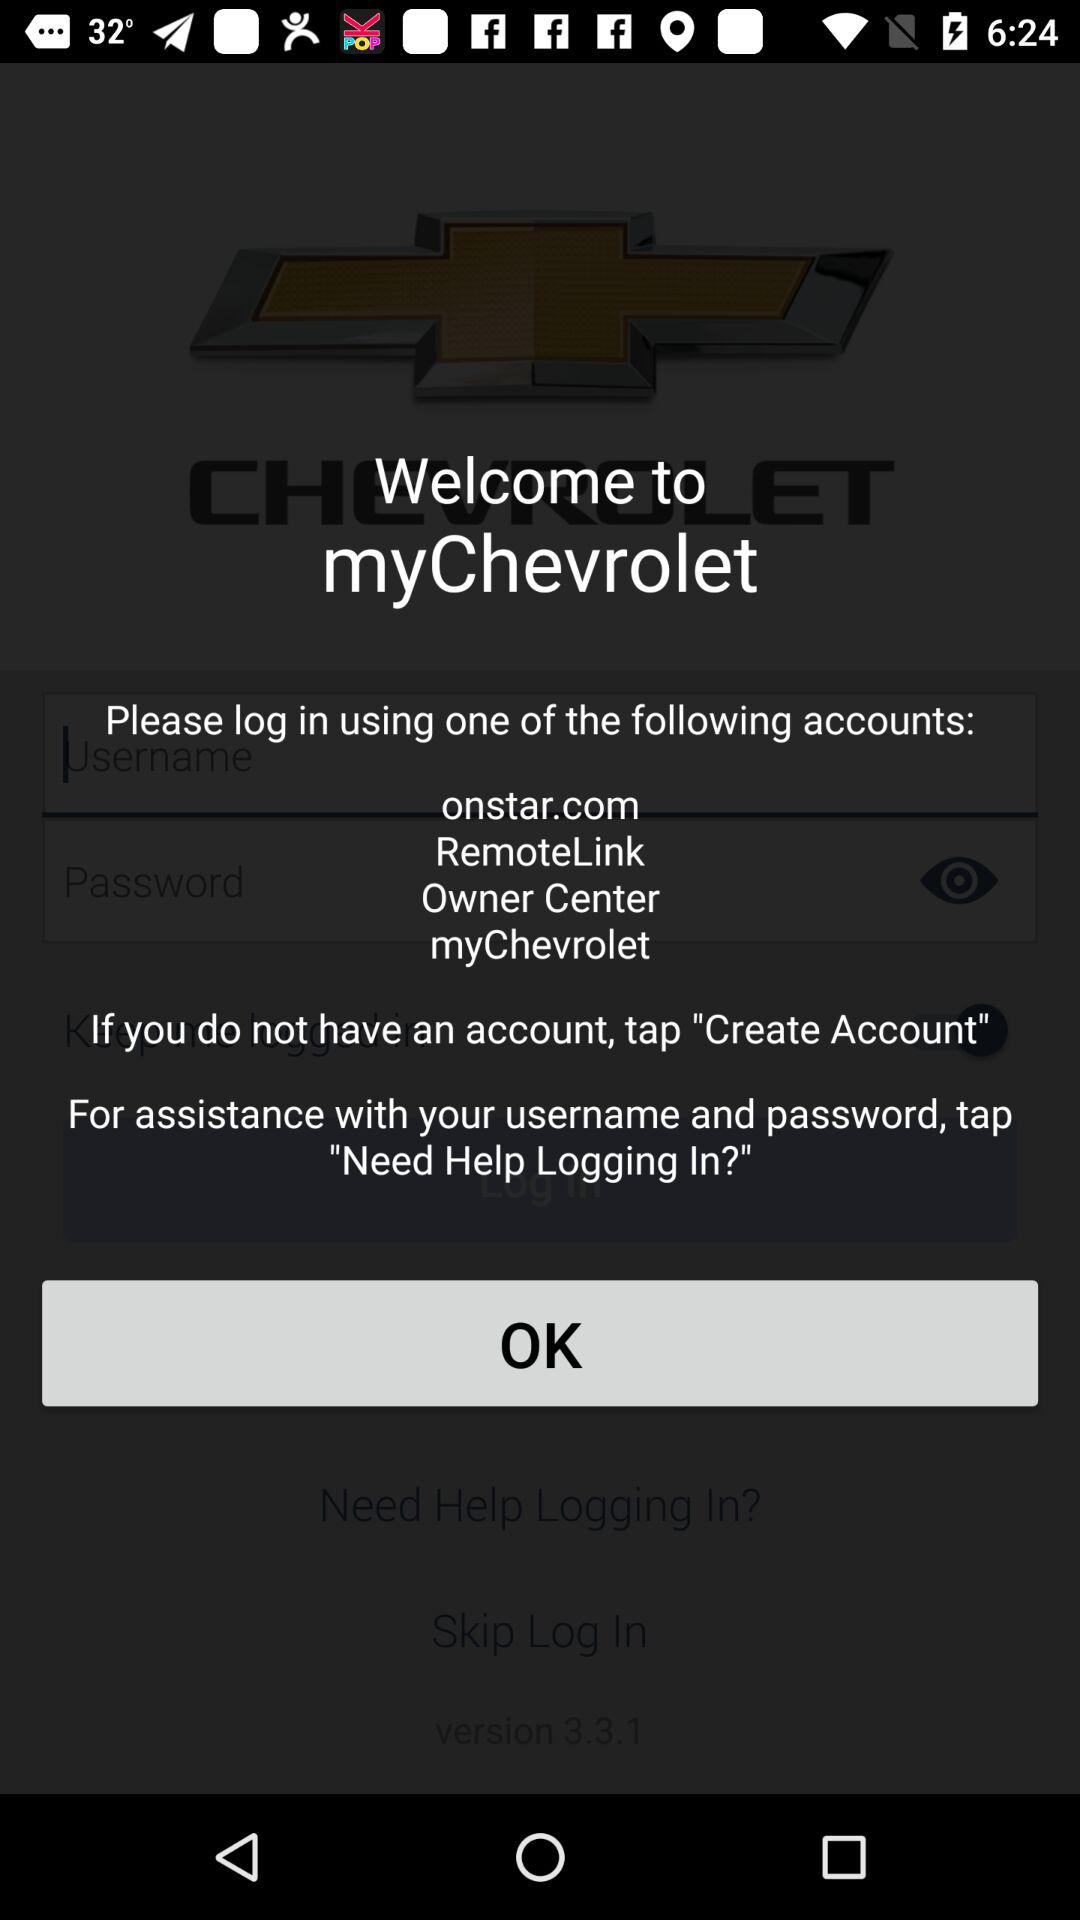How many text input fields are there on this screen?
Answer the question using a single word or phrase. 2 